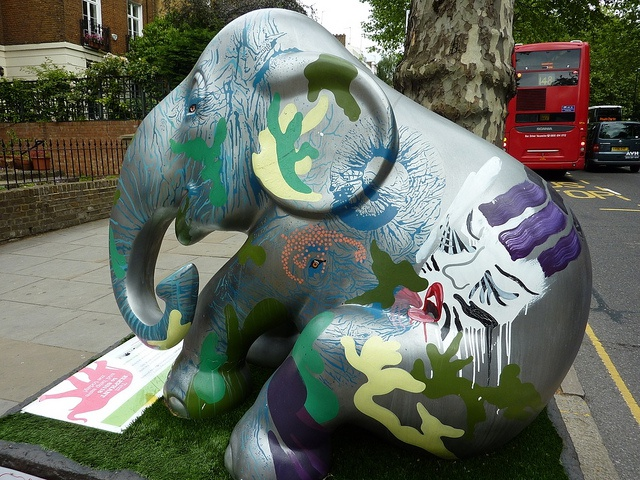Describe the objects in this image and their specific colors. I can see elephant in black, gray, lightgray, and darkgray tones, bus in black, maroon, and gray tones, and car in black, gray, and purple tones in this image. 